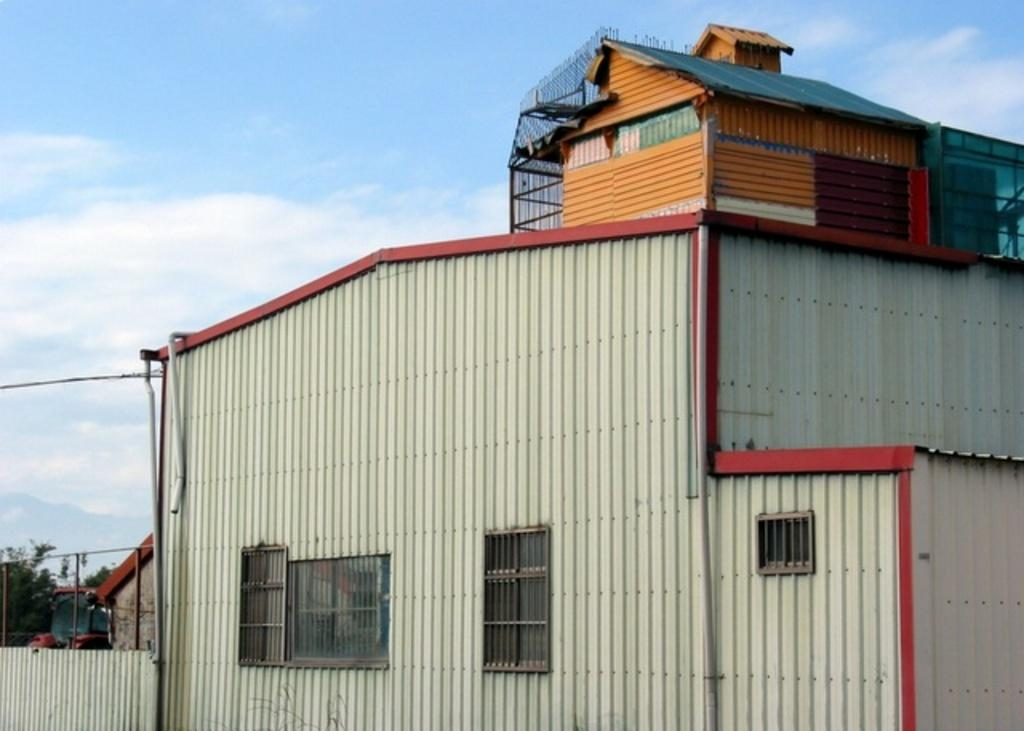What is the main structure in the center of the image? There is a shed in the center of the image. What else can be seen in the background of the image? There is a vehicle and a tree in the background of the image. What is visible in the sky in the image? The sky is visible in the background of the image, and there are clouds in the sky. What type of class is being taught in the shed in the image? There is no indication of a class being taught in the shed in the image. 